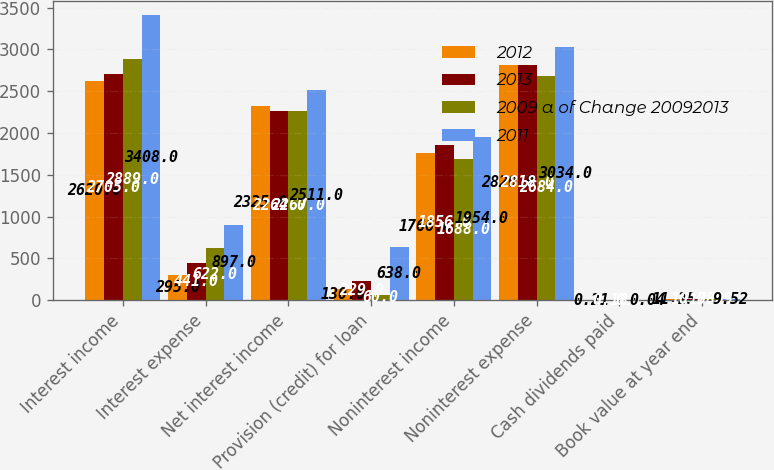<chart> <loc_0><loc_0><loc_500><loc_500><stacked_bar_chart><ecel><fcel>Interest income<fcel>Interest expense<fcel>Net interest income<fcel>Provision (credit) for loan<fcel>Noninterest income<fcel>Noninterest expense<fcel>Cash dividends paid<fcel>Book value at year end<nl><fcel>2012<fcel>2620<fcel>295<fcel>2325<fcel>130<fcel>1766<fcel>2820<fcel>0.21<fcel>11.25<nl><fcel>2013<fcel>2705<fcel>441<fcel>2264<fcel>229<fcel>1856<fcel>2818<fcel>0.18<fcel>10.78<nl><fcel>2009 a of Change 20092013<fcel>2889<fcel>622<fcel>2267<fcel>60<fcel>1688<fcel>2684<fcel>0.1<fcel>10.09<nl><fcel>2011<fcel>3408<fcel>897<fcel>2511<fcel>638<fcel>1954<fcel>3034<fcel>0.04<fcel>9.52<nl></chart> 